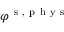Convert formula to latex. <formula><loc_0><loc_0><loc_500><loc_500>\varphi ^ { s , p h y s }</formula> 